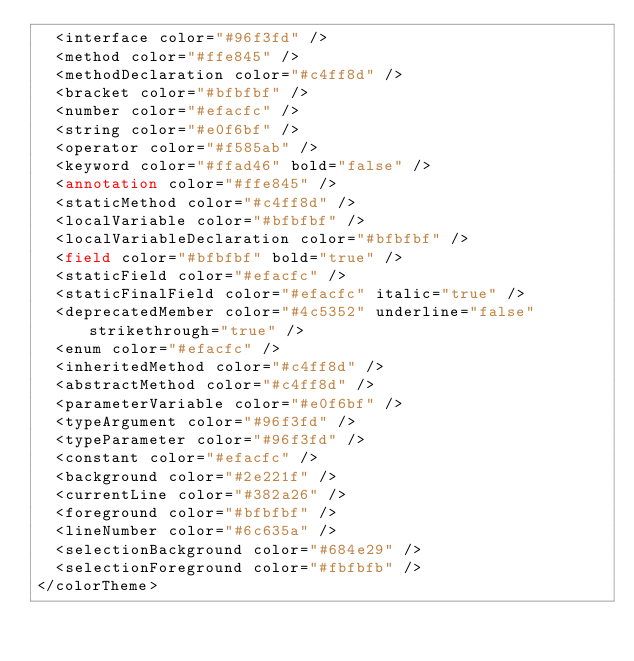Convert code to text. <code><loc_0><loc_0><loc_500><loc_500><_XML_>  <interface color="#96f3fd" />
  <method color="#ffe845" />
  <methodDeclaration color="#c4ff8d" />
  <bracket color="#bfbfbf" />
  <number color="#efacfc" />
  <string color="#e0f6bf" />
  <operator color="#f585ab" />
  <keyword color="#ffad46" bold="false" />
  <annotation color="#ffe845" />
  <staticMethod color="#c4ff8d" />
  <localVariable color="#bfbfbf" />
  <localVariableDeclaration color="#bfbfbf" />
  <field color="#bfbfbf" bold="true" />
  <staticField color="#efacfc" />
  <staticFinalField color="#efacfc" italic="true" />
  <deprecatedMember color="#4c5352" underline="false" strikethrough="true" />
  <enum color="#efacfc" />
  <inheritedMethod color="#c4ff8d" />
  <abstractMethod color="#c4ff8d" />
  <parameterVariable color="#e0f6bf" />
  <typeArgument color="#96f3fd" />
  <typeParameter color="#96f3fd" />
  <constant color="#efacfc" />
  <background color="#2e221f" />
  <currentLine color="#382a26" />
  <foreground color="#bfbfbf" />
  <lineNumber color="#6c635a" />
  <selectionBackground color="#684e29" />
  <selectionForeground color="#fbfbfb" />
</colorTheme></code> 